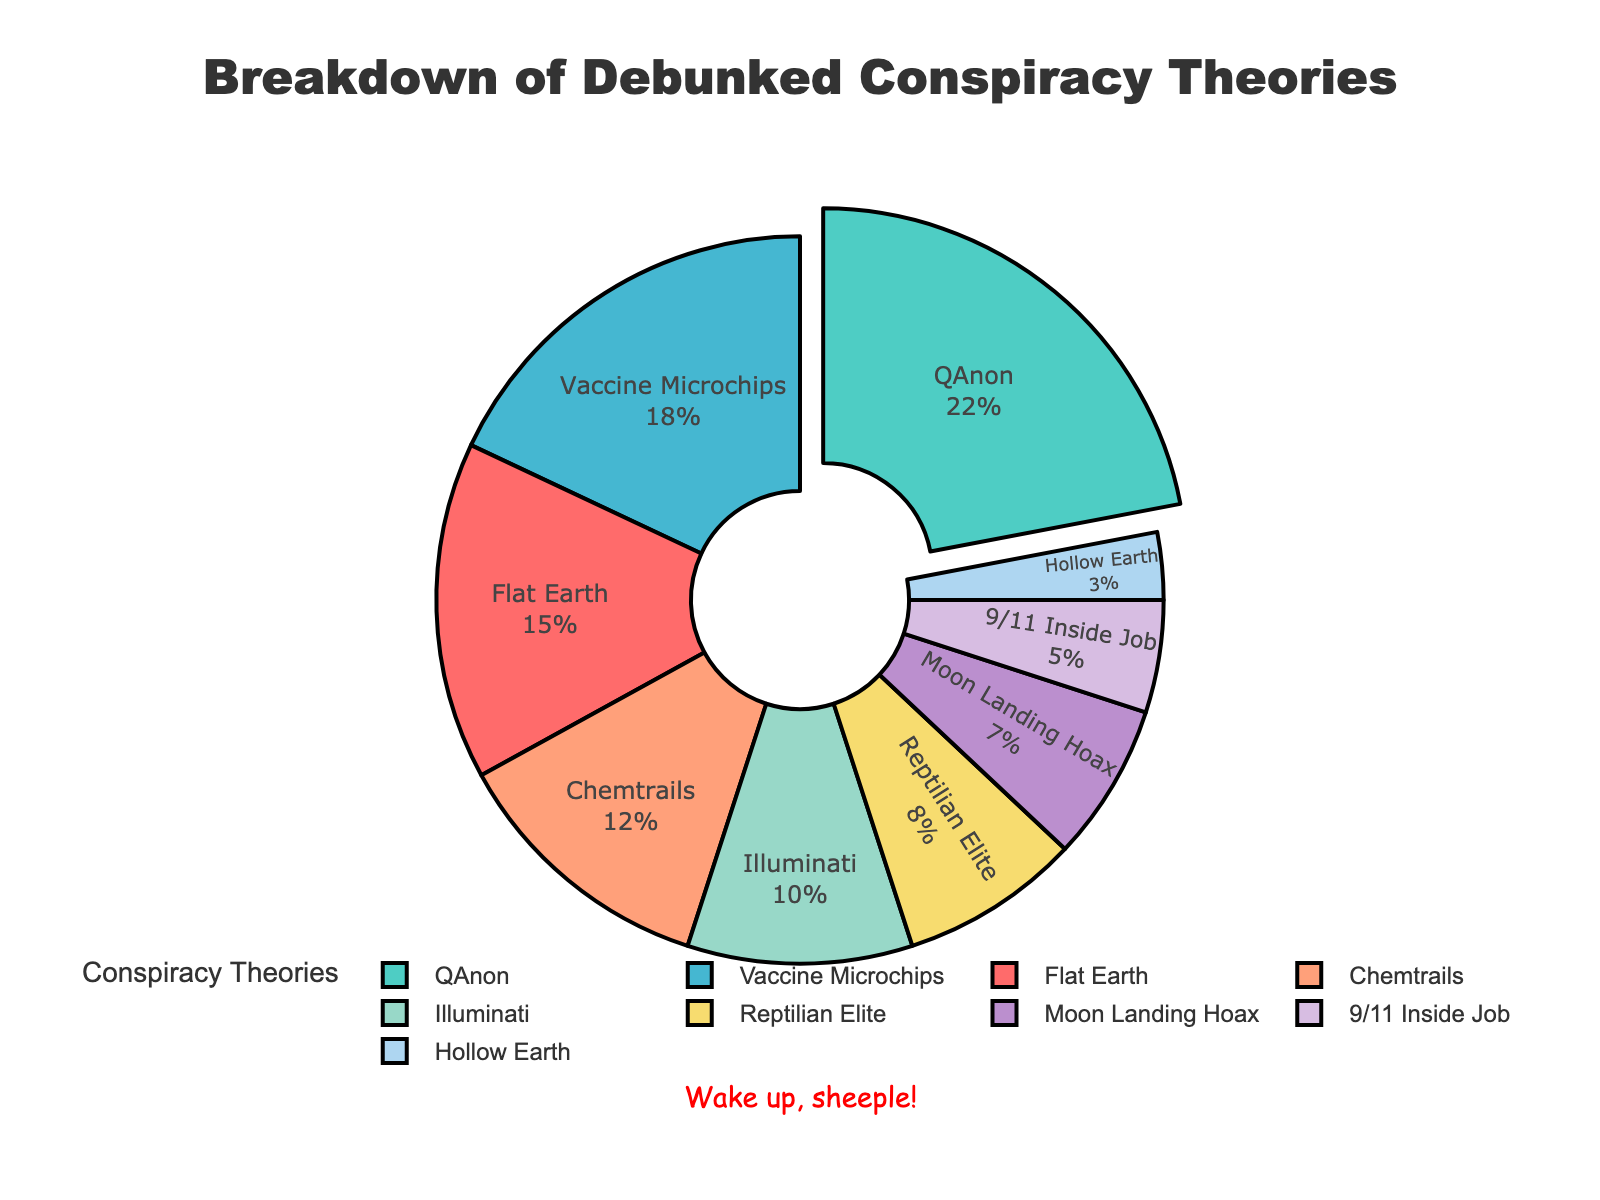What subject has the highest percentage in the breakdown provided? The segment with the highest percentage is the largest sector in the pie chart and is typically pulled out slightly for emphasis. From the data, QAnon has the highest percentage.
Answer: QAnon What is the combined percentage of the "Flat Earth" and "Chemtrails" subjects? Add the percentages for "Flat Earth" (15%) and "Chemtrails" (12%) together. 15 + 12 = 27%
Answer: 27% Which conspiracy theory subject has a smaller percentage: "Moon Landing Hoax" or "Reptilian Elite"? Compare the percentages of "Moon Landing Hoax" (7%) and "Reptilian Elite" (8%). 7% is less than 8%.
Answer: Moon Landing Hoax How much larger is the percentage of "Vaccine Microchips" compared to "Illuminati"? Subtract the percentage of "Illuminati" (10%) from "Vaccine Microchips" (18%). 18 - 10 = 8
Answer: 8% What percentage does the "Chemtrails" segment represent in the pie chart? Look at the data and find the percentage given for "Chemtrails." The pie chart confirms this at 12%.
Answer: 12% Which subject has the second-largest percentage in the pie chart? Identify the second largest segment after the highest. Following QAnon (22%), "Vaccine Microchips" is next at 18%.
Answer: Vaccine Microchips What is the total percentage for subjects related to "Earth" (Flat Earth, Hollow Earth)? Add the percentages for "Flat Earth" (15%) and "Hollow Earth" (3%). 15 + 3 = 18%
Answer: 18% What color is used to represent the "Illuminati" segment in the pie chart? Visually identify the color associated with the "Illuminati" in the pie chart, which is '#F7DC6F' or yellow.
Answer: Yellow If "9/11 Inside Job" and "Hollow Earth" percentages were combined, would they exceed the percentage for "Chemtrails"? Add the percentages for "9/11 Inside Job" (5%) and "Hollow Earth" (3%) and compare to "Chemtrails" (12%). 5 + 3 = 8%, which is less than 12%.
Answer: No 